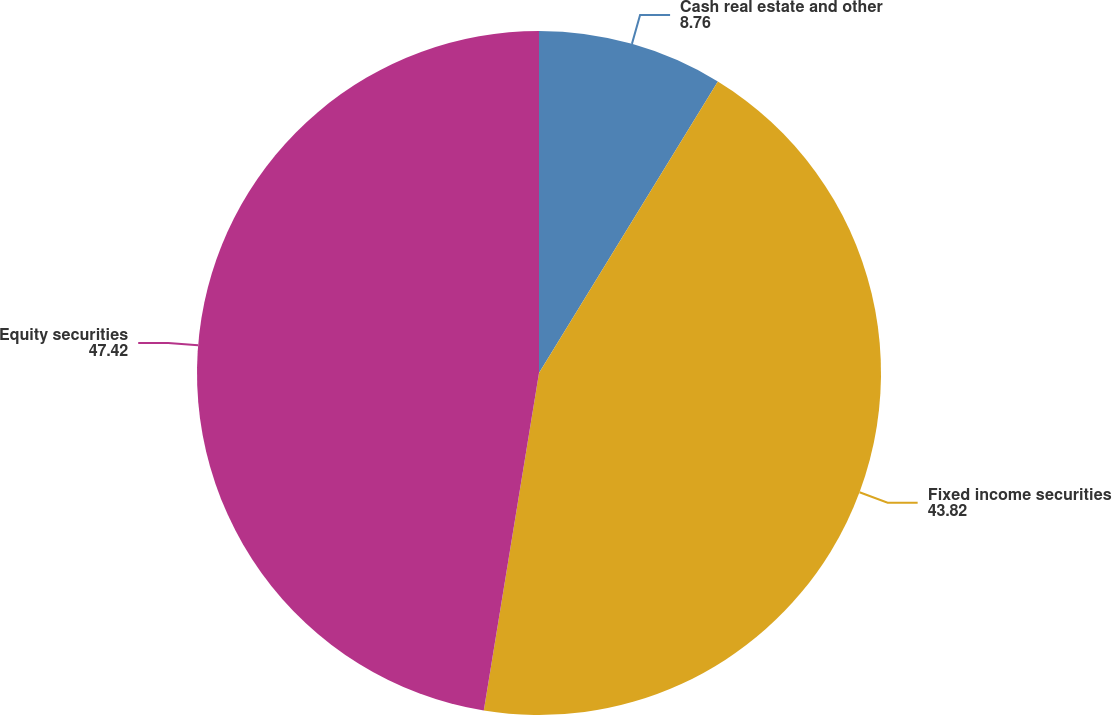Convert chart to OTSL. <chart><loc_0><loc_0><loc_500><loc_500><pie_chart><fcel>Cash real estate and other<fcel>Fixed income securities<fcel>Equity securities<nl><fcel>8.76%<fcel>43.82%<fcel>47.42%<nl></chart> 